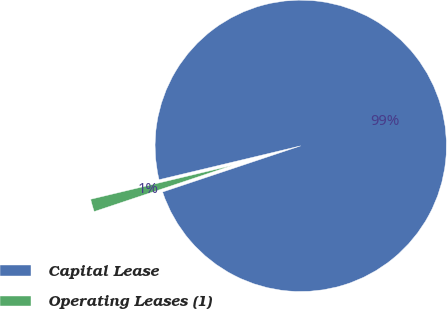Convert chart to OTSL. <chart><loc_0><loc_0><loc_500><loc_500><pie_chart><fcel>Capital Lease<fcel>Operating Leases (1)<nl><fcel>98.6%<fcel>1.4%<nl></chart> 